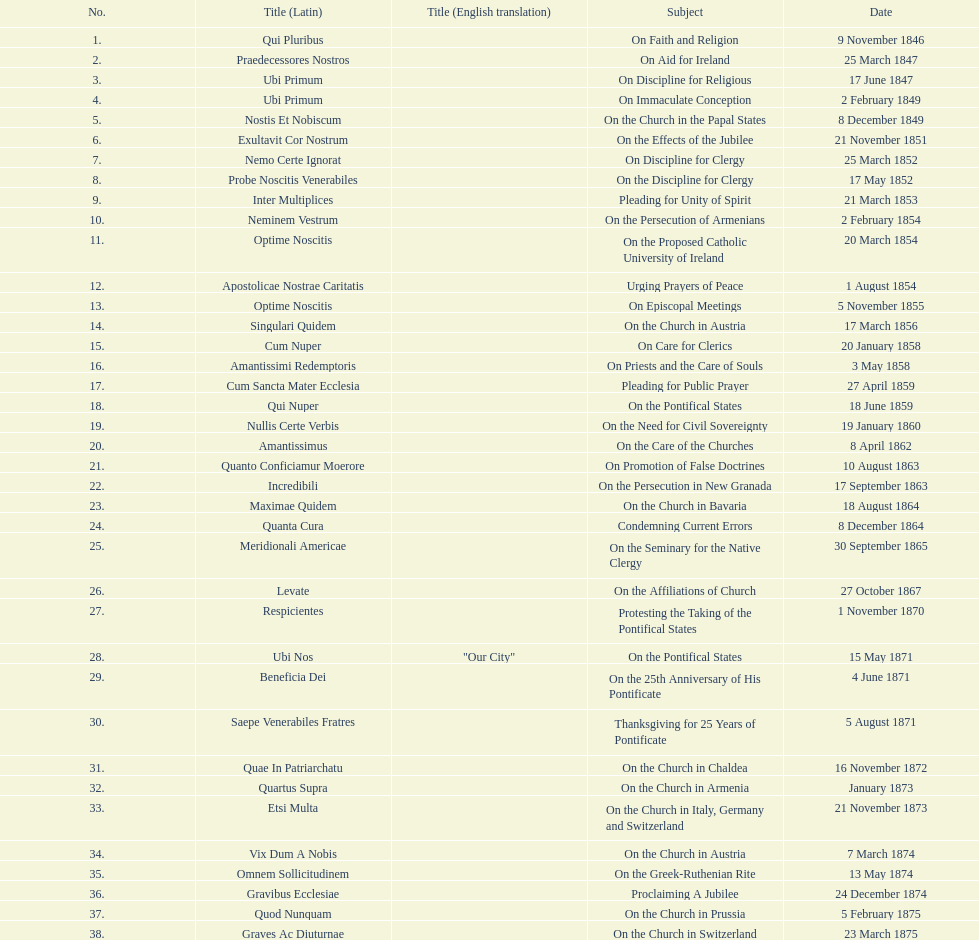What was the regularity of encyclical releases in january? 3. 